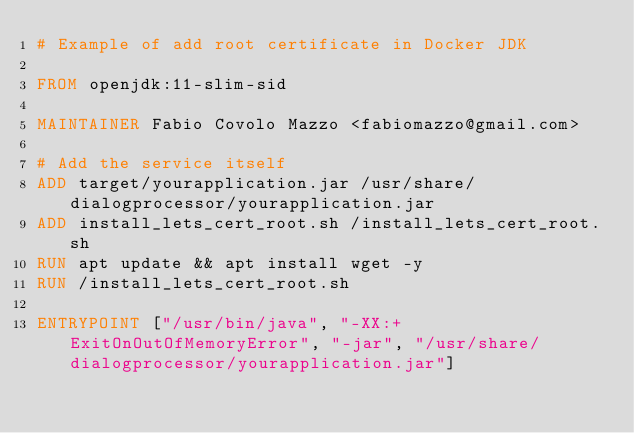<code> <loc_0><loc_0><loc_500><loc_500><_Dockerfile_># Example of add root certificate in Docker JDK

FROM openjdk:11-slim-sid

MAINTAINER Fabio Covolo Mazzo <fabiomazzo@gmail.com>

# Add the service itself
ADD target/yourapplication.jar /usr/share/dialogprocessor/yourapplication.jar
ADD install_lets_cert_root.sh /install_lets_cert_root.sh
RUN apt update && apt install wget -y
RUN /install_lets_cert_root.sh

ENTRYPOINT ["/usr/bin/java", "-XX:+ExitOnOutOfMemoryError", "-jar", "/usr/share/dialogprocessor/yourapplication.jar"]


</code> 